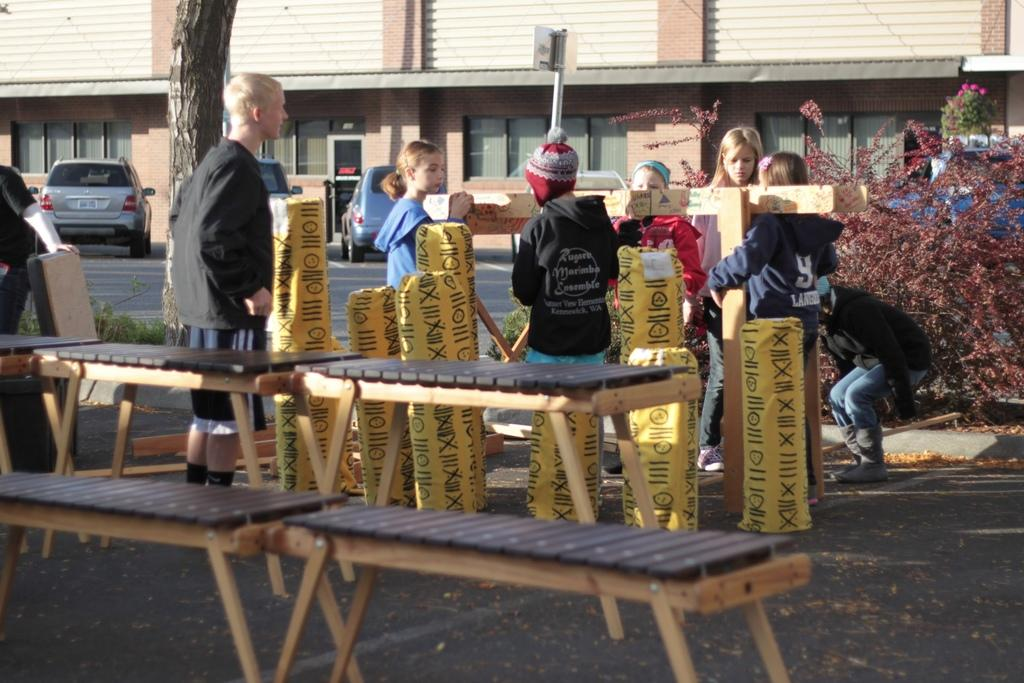How many people are in the image? There is a group of people standing in the image. What type of seating is available in the image? There are benches in the image. What color are some of the covers in the image? Some objects are wrapped with yellow color covers. What type of vegetation can be seen in the image? There are plants with flowers in the image. What type of vehicles are visible in the image? Cars are visible in the image. What type of structures are present in the image? Buildings are present in the image. What type of ground cover is present in the image? Grass is present in the image. What type of destruction is happening in the image? There is no destruction present in the image. What type of coil is being used by the people in the image? There is no coil present in the image. 